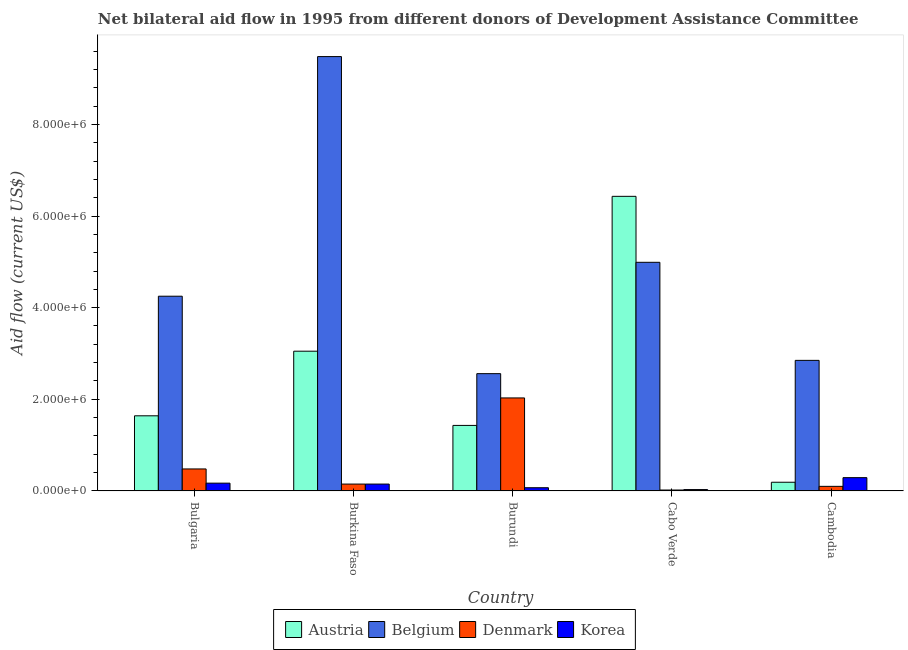How many groups of bars are there?
Your answer should be compact. 5. Are the number of bars on each tick of the X-axis equal?
Ensure brevity in your answer.  Yes. How many bars are there on the 3rd tick from the left?
Your answer should be very brief. 4. How many bars are there on the 3rd tick from the right?
Ensure brevity in your answer.  4. What is the label of the 1st group of bars from the left?
Give a very brief answer. Bulgaria. In how many cases, is the number of bars for a given country not equal to the number of legend labels?
Your response must be concise. 0. What is the amount of aid given by belgium in Cabo Verde?
Provide a short and direct response. 4.99e+06. Across all countries, what is the maximum amount of aid given by belgium?
Keep it short and to the point. 9.48e+06. Across all countries, what is the minimum amount of aid given by belgium?
Ensure brevity in your answer.  2.56e+06. In which country was the amount of aid given by austria maximum?
Provide a short and direct response. Cabo Verde. In which country was the amount of aid given by belgium minimum?
Offer a terse response. Burundi. What is the total amount of aid given by belgium in the graph?
Make the answer very short. 2.41e+07. What is the difference between the amount of aid given by korea in Burundi and that in Cambodia?
Your answer should be compact. -2.20e+05. What is the difference between the amount of aid given by austria in Bulgaria and the amount of aid given by denmark in Burkina Faso?
Make the answer very short. 1.49e+06. What is the average amount of aid given by belgium per country?
Make the answer very short. 4.83e+06. What is the difference between the amount of aid given by denmark and amount of aid given by korea in Cambodia?
Provide a succinct answer. -1.90e+05. In how many countries, is the amount of aid given by belgium greater than 5600000 US$?
Your response must be concise. 1. What is the ratio of the amount of aid given by austria in Bulgaria to that in Burundi?
Give a very brief answer. 1.15. Is the amount of aid given by austria in Bulgaria less than that in Cabo Verde?
Your response must be concise. Yes. Is the difference between the amount of aid given by belgium in Bulgaria and Cabo Verde greater than the difference between the amount of aid given by denmark in Bulgaria and Cabo Verde?
Ensure brevity in your answer.  No. What is the difference between the highest and the second highest amount of aid given by korea?
Give a very brief answer. 1.20e+05. What is the difference between the highest and the lowest amount of aid given by korea?
Provide a succinct answer. 2.60e+05. Is the sum of the amount of aid given by korea in Burundi and Cabo Verde greater than the maximum amount of aid given by belgium across all countries?
Make the answer very short. No. What does the 2nd bar from the left in Bulgaria represents?
Your answer should be very brief. Belgium. What does the 2nd bar from the right in Bulgaria represents?
Keep it short and to the point. Denmark. Is it the case that in every country, the sum of the amount of aid given by austria and amount of aid given by belgium is greater than the amount of aid given by denmark?
Give a very brief answer. Yes. How many bars are there?
Make the answer very short. 20. How are the legend labels stacked?
Keep it short and to the point. Horizontal. What is the title of the graph?
Make the answer very short. Net bilateral aid flow in 1995 from different donors of Development Assistance Committee. What is the Aid flow (current US$) in Austria in Bulgaria?
Make the answer very short. 1.64e+06. What is the Aid flow (current US$) in Belgium in Bulgaria?
Make the answer very short. 4.25e+06. What is the Aid flow (current US$) of Denmark in Bulgaria?
Offer a terse response. 4.80e+05. What is the Aid flow (current US$) in Austria in Burkina Faso?
Provide a short and direct response. 3.05e+06. What is the Aid flow (current US$) in Belgium in Burkina Faso?
Give a very brief answer. 9.48e+06. What is the Aid flow (current US$) in Korea in Burkina Faso?
Your answer should be very brief. 1.50e+05. What is the Aid flow (current US$) of Austria in Burundi?
Your answer should be compact. 1.43e+06. What is the Aid flow (current US$) of Belgium in Burundi?
Keep it short and to the point. 2.56e+06. What is the Aid flow (current US$) in Denmark in Burundi?
Make the answer very short. 2.03e+06. What is the Aid flow (current US$) of Austria in Cabo Verde?
Your answer should be compact. 6.43e+06. What is the Aid flow (current US$) in Belgium in Cabo Verde?
Keep it short and to the point. 4.99e+06. What is the Aid flow (current US$) of Denmark in Cabo Verde?
Your response must be concise. 2.00e+04. What is the Aid flow (current US$) of Belgium in Cambodia?
Your answer should be very brief. 2.85e+06. What is the Aid flow (current US$) in Denmark in Cambodia?
Your answer should be very brief. 1.00e+05. Across all countries, what is the maximum Aid flow (current US$) in Austria?
Your answer should be very brief. 6.43e+06. Across all countries, what is the maximum Aid flow (current US$) in Belgium?
Keep it short and to the point. 9.48e+06. Across all countries, what is the maximum Aid flow (current US$) of Denmark?
Give a very brief answer. 2.03e+06. Across all countries, what is the maximum Aid flow (current US$) in Korea?
Offer a very short reply. 2.90e+05. Across all countries, what is the minimum Aid flow (current US$) of Belgium?
Give a very brief answer. 2.56e+06. Across all countries, what is the minimum Aid flow (current US$) of Denmark?
Your response must be concise. 2.00e+04. Across all countries, what is the minimum Aid flow (current US$) in Korea?
Provide a succinct answer. 3.00e+04. What is the total Aid flow (current US$) of Austria in the graph?
Your answer should be compact. 1.27e+07. What is the total Aid flow (current US$) of Belgium in the graph?
Ensure brevity in your answer.  2.41e+07. What is the total Aid flow (current US$) in Denmark in the graph?
Provide a short and direct response. 2.78e+06. What is the total Aid flow (current US$) in Korea in the graph?
Make the answer very short. 7.10e+05. What is the difference between the Aid flow (current US$) in Austria in Bulgaria and that in Burkina Faso?
Provide a succinct answer. -1.41e+06. What is the difference between the Aid flow (current US$) in Belgium in Bulgaria and that in Burkina Faso?
Keep it short and to the point. -5.23e+06. What is the difference between the Aid flow (current US$) in Denmark in Bulgaria and that in Burkina Faso?
Ensure brevity in your answer.  3.30e+05. What is the difference between the Aid flow (current US$) in Austria in Bulgaria and that in Burundi?
Offer a terse response. 2.10e+05. What is the difference between the Aid flow (current US$) of Belgium in Bulgaria and that in Burundi?
Your response must be concise. 1.69e+06. What is the difference between the Aid flow (current US$) in Denmark in Bulgaria and that in Burundi?
Make the answer very short. -1.55e+06. What is the difference between the Aid flow (current US$) of Korea in Bulgaria and that in Burundi?
Your answer should be compact. 1.00e+05. What is the difference between the Aid flow (current US$) of Austria in Bulgaria and that in Cabo Verde?
Ensure brevity in your answer.  -4.79e+06. What is the difference between the Aid flow (current US$) in Belgium in Bulgaria and that in Cabo Verde?
Offer a terse response. -7.40e+05. What is the difference between the Aid flow (current US$) in Austria in Bulgaria and that in Cambodia?
Your response must be concise. 1.45e+06. What is the difference between the Aid flow (current US$) of Belgium in Bulgaria and that in Cambodia?
Your answer should be compact. 1.40e+06. What is the difference between the Aid flow (current US$) in Austria in Burkina Faso and that in Burundi?
Give a very brief answer. 1.62e+06. What is the difference between the Aid flow (current US$) in Belgium in Burkina Faso and that in Burundi?
Make the answer very short. 6.92e+06. What is the difference between the Aid flow (current US$) in Denmark in Burkina Faso and that in Burundi?
Keep it short and to the point. -1.88e+06. What is the difference between the Aid flow (current US$) in Korea in Burkina Faso and that in Burundi?
Your answer should be compact. 8.00e+04. What is the difference between the Aid flow (current US$) in Austria in Burkina Faso and that in Cabo Verde?
Your response must be concise. -3.38e+06. What is the difference between the Aid flow (current US$) in Belgium in Burkina Faso and that in Cabo Verde?
Make the answer very short. 4.49e+06. What is the difference between the Aid flow (current US$) in Austria in Burkina Faso and that in Cambodia?
Ensure brevity in your answer.  2.86e+06. What is the difference between the Aid flow (current US$) of Belgium in Burkina Faso and that in Cambodia?
Provide a succinct answer. 6.63e+06. What is the difference between the Aid flow (current US$) in Austria in Burundi and that in Cabo Verde?
Your response must be concise. -5.00e+06. What is the difference between the Aid flow (current US$) of Belgium in Burundi and that in Cabo Verde?
Make the answer very short. -2.43e+06. What is the difference between the Aid flow (current US$) of Denmark in Burundi and that in Cabo Verde?
Give a very brief answer. 2.01e+06. What is the difference between the Aid flow (current US$) of Korea in Burundi and that in Cabo Verde?
Your response must be concise. 4.00e+04. What is the difference between the Aid flow (current US$) in Austria in Burundi and that in Cambodia?
Your answer should be very brief. 1.24e+06. What is the difference between the Aid flow (current US$) in Denmark in Burundi and that in Cambodia?
Offer a very short reply. 1.93e+06. What is the difference between the Aid flow (current US$) of Korea in Burundi and that in Cambodia?
Give a very brief answer. -2.20e+05. What is the difference between the Aid flow (current US$) of Austria in Cabo Verde and that in Cambodia?
Ensure brevity in your answer.  6.24e+06. What is the difference between the Aid flow (current US$) in Belgium in Cabo Verde and that in Cambodia?
Your response must be concise. 2.14e+06. What is the difference between the Aid flow (current US$) of Denmark in Cabo Verde and that in Cambodia?
Ensure brevity in your answer.  -8.00e+04. What is the difference between the Aid flow (current US$) of Korea in Cabo Verde and that in Cambodia?
Your response must be concise. -2.60e+05. What is the difference between the Aid flow (current US$) in Austria in Bulgaria and the Aid flow (current US$) in Belgium in Burkina Faso?
Provide a short and direct response. -7.84e+06. What is the difference between the Aid flow (current US$) in Austria in Bulgaria and the Aid flow (current US$) in Denmark in Burkina Faso?
Offer a terse response. 1.49e+06. What is the difference between the Aid flow (current US$) of Austria in Bulgaria and the Aid flow (current US$) of Korea in Burkina Faso?
Give a very brief answer. 1.49e+06. What is the difference between the Aid flow (current US$) in Belgium in Bulgaria and the Aid flow (current US$) in Denmark in Burkina Faso?
Offer a terse response. 4.10e+06. What is the difference between the Aid flow (current US$) in Belgium in Bulgaria and the Aid flow (current US$) in Korea in Burkina Faso?
Offer a terse response. 4.10e+06. What is the difference between the Aid flow (current US$) in Denmark in Bulgaria and the Aid flow (current US$) in Korea in Burkina Faso?
Give a very brief answer. 3.30e+05. What is the difference between the Aid flow (current US$) in Austria in Bulgaria and the Aid flow (current US$) in Belgium in Burundi?
Your response must be concise. -9.20e+05. What is the difference between the Aid flow (current US$) of Austria in Bulgaria and the Aid flow (current US$) of Denmark in Burundi?
Keep it short and to the point. -3.90e+05. What is the difference between the Aid flow (current US$) in Austria in Bulgaria and the Aid flow (current US$) in Korea in Burundi?
Ensure brevity in your answer.  1.57e+06. What is the difference between the Aid flow (current US$) of Belgium in Bulgaria and the Aid flow (current US$) of Denmark in Burundi?
Make the answer very short. 2.22e+06. What is the difference between the Aid flow (current US$) in Belgium in Bulgaria and the Aid flow (current US$) in Korea in Burundi?
Offer a very short reply. 4.18e+06. What is the difference between the Aid flow (current US$) of Denmark in Bulgaria and the Aid flow (current US$) of Korea in Burundi?
Offer a very short reply. 4.10e+05. What is the difference between the Aid flow (current US$) of Austria in Bulgaria and the Aid flow (current US$) of Belgium in Cabo Verde?
Offer a terse response. -3.35e+06. What is the difference between the Aid flow (current US$) of Austria in Bulgaria and the Aid flow (current US$) of Denmark in Cabo Verde?
Offer a very short reply. 1.62e+06. What is the difference between the Aid flow (current US$) in Austria in Bulgaria and the Aid flow (current US$) in Korea in Cabo Verde?
Make the answer very short. 1.61e+06. What is the difference between the Aid flow (current US$) in Belgium in Bulgaria and the Aid flow (current US$) in Denmark in Cabo Verde?
Your answer should be compact. 4.23e+06. What is the difference between the Aid flow (current US$) of Belgium in Bulgaria and the Aid flow (current US$) of Korea in Cabo Verde?
Provide a succinct answer. 4.22e+06. What is the difference between the Aid flow (current US$) of Denmark in Bulgaria and the Aid flow (current US$) of Korea in Cabo Verde?
Your answer should be compact. 4.50e+05. What is the difference between the Aid flow (current US$) of Austria in Bulgaria and the Aid flow (current US$) of Belgium in Cambodia?
Your answer should be very brief. -1.21e+06. What is the difference between the Aid flow (current US$) of Austria in Bulgaria and the Aid flow (current US$) of Denmark in Cambodia?
Give a very brief answer. 1.54e+06. What is the difference between the Aid flow (current US$) of Austria in Bulgaria and the Aid flow (current US$) of Korea in Cambodia?
Offer a very short reply. 1.35e+06. What is the difference between the Aid flow (current US$) in Belgium in Bulgaria and the Aid flow (current US$) in Denmark in Cambodia?
Give a very brief answer. 4.15e+06. What is the difference between the Aid flow (current US$) of Belgium in Bulgaria and the Aid flow (current US$) of Korea in Cambodia?
Your answer should be very brief. 3.96e+06. What is the difference between the Aid flow (current US$) of Denmark in Bulgaria and the Aid flow (current US$) of Korea in Cambodia?
Your answer should be compact. 1.90e+05. What is the difference between the Aid flow (current US$) of Austria in Burkina Faso and the Aid flow (current US$) of Denmark in Burundi?
Give a very brief answer. 1.02e+06. What is the difference between the Aid flow (current US$) in Austria in Burkina Faso and the Aid flow (current US$) in Korea in Burundi?
Keep it short and to the point. 2.98e+06. What is the difference between the Aid flow (current US$) of Belgium in Burkina Faso and the Aid flow (current US$) of Denmark in Burundi?
Provide a succinct answer. 7.45e+06. What is the difference between the Aid flow (current US$) in Belgium in Burkina Faso and the Aid flow (current US$) in Korea in Burundi?
Ensure brevity in your answer.  9.41e+06. What is the difference between the Aid flow (current US$) in Denmark in Burkina Faso and the Aid flow (current US$) in Korea in Burundi?
Provide a short and direct response. 8.00e+04. What is the difference between the Aid flow (current US$) in Austria in Burkina Faso and the Aid flow (current US$) in Belgium in Cabo Verde?
Provide a short and direct response. -1.94e+06. What is the difference between the Aid flow (current US$) of Austria in Burkina Faso and the Aid flow (current US$) of Denmark in Cabo Verde?
Make the answer very short. 3.03e+06. What is the difference between the Aid flow (current US$) in Austria in Burkina Faso and the Aid flow (current US$) in Korea in Cabo Verde?
Provide a short and direct response. 3.02e+06. What is the difference between the Aid flow (current US$) of Belgium in Burkina Faso and the Aid flow (current US$) of Denmark in Cabo Verde?
Provide a short and direct response. 9.46e+06. What is the difference between the Aid flow (current US$) in Belgium in Burkina Faso and the Aid flow (current US$) in Korea in Cabo Verde?
Offer a very short reply. 9.45e+06. What is the difference between the Aid flow (current US$) of Austria in Burkina Faso and the Aid flow (current US$) of Denmark in Cambodia?
Keep it short and to the point. 2.95e+06. What is the difference between the Aid flow (current US$) of Austria in Burkina Faso and the Aid flow (current US$) of Korea in Cambodia?
Offer a very short reply. 2.76e+06. What is the difference between the Aid flow (current US$) in Belgium in Burkina Faso and the Aid flow (current US$) in Denmark in Cambodia?
Your answer should be very brief. 9.38e+06. What is the difference between the Aid flow (current US$) of Belgium in Burkina Faso and the Aid flow (current US$) of Korea in Cambodia?
Provide a succinct answer. 9.19e+06. What is the difference between the Aid flow (current US$) in Austria in Burundi and the Aid flow (current US$) in Belgium in Cabo Verde?
Make the answer very short. -3.56e+06. What is the difference between the Aid flow (current US$) of Austria in Burundi and the Aid flow (current US$) of Denmark in Cabo Verde?
Your response must be concise. 1.41e+06. What is the difference between the Aid flow (current US$) in Austria in Burundi and the Aid flow (current US$) in Korea in Cabo Verde?
Ensure brevity in your answer.  1.40e+06. What is the difference between the Aid flow (current US$) in Belgium in Burundi and the Aid flow (current US$) in Denmark in Cabo Verde?
Your answer should be very brief. 2.54e+06. What is the difference between the Aid flow (current US$) in Belgium in Burundi and the Aid flow (current US$) in Korea in Cabo Verde?
Ensure brevity in your answer.  2.53e+06. What is the difference between the Aid flow (current US$) in Denmark in Burundi and the Aid flow (current US$) in Korea in Cabo Verde?
Provide a short and direct response. 2.00e+06. What is the difference between the Aid flow (current US$) of Austria in Burundi and the Aid flow (current US$) of Belgium in Cambodia?
Your answer should be very brief. -1.42e+06. What is the difference between the Aid flow (current US$) of Austria in Burundi and the Aid flow (current US$) of Denmark in Cambodia?
Your answer should be very brief. 1.33e+06. What is the difference between the Aid flow (current US$) in Austria in Burundi and the Aid flow (current US$) in Korea in Cambodia?
Give a very brief answer. 1.14e+06. What is the difference between the Aid flow (current US$) in Belgium in Burundi and the Aid flow (current US$) in Denmark in Cambodia?
Your response must be concise. 2.46e+06. What is the difference between the Aid flow (current US$) of Belgium in Burundi and the Aid flow (current US$) of Korea in Cambodia?
Your answer should be very brief. 2.27e+06. What is the difference between the Aid flow (current US$) of Denmark in Burundi and the Aid flow (current US$) of Korea in Cambodia?
Your answer should be very brief. 1.74e+06. What is the difference between the Aid flow (current US$) of Austria in Cabo Verde and the Aid flow (current US$) of Belgium in Cambodia?
Offer a terse response. 3.58e+06. What is the difference between the Aid flow (current US$) of Austria in Cabo Verde and the Aid flow (current US$) of Denmark in Cambodia?
Offer a very short reply. 6.33e+06. What is the difference between the Aid flow (current US$) of Austria in Cabo Verde and the Aid flow (current US$) of Korea in Cambodia?
Give a very brief answer. 6.14e+06. What is the difference between the Aid flow (current US$) of Belgium in Cabo Verde and the Aid flow (current US$) of Denmark in Cambodia?
Offer a terse response. 4.89e+06. What is the difference between the Aid flow (current US$) of Belgium in Cabo Verde and the Aid flow (current US$) of Korea in Cambodia?
Provide a short and direct response. 4.70e+06. What is the difference between the Aid flow (current US$) in Denmark in Cabo Verde and the Aid flow (current US$) in Korea in Cambodia?
Offer a very short reply. -2.70e+05. What is the average Aid flow (current US$) of Austria per country?
Offer a terse response. 2.55e+06. What is the average Aid flow (current US$) of Belgium per country?
Provide a short and direct response. 4.83e+06. What is the average Aid flow (current US$) of Denmark per country?
Offer a terse response. 5.56e+05. What is the average Aid flow (current US$) of Korea per country?
Offer a terse response. 1.42e+05. What is the difference between the Aid flow (current US$) in Austria and Aid flow (current US$) in Belgium in Bulgaria?
Give a very brief answer. -2.61e+06. What is the difference between the Aid flow (current US$) in Austria and Aid flow (current US$) in Denmark in Bulgaria?
Your answer should be compact. 1.16e+06. What is the difference between the Aid flow (current US$) of Austria and Aid flow (current US$) of Korea in Bulgaria?
Provide a short and direct response. 1.47e+06. What is the difference between the Aid flow (current US$) in Belgium and Aid flow (current US$) in Denmark in Bulgaria?
Keep it short and to the point. 3.77e+06. What is the difference between the Aid flow (current US$) of Belgium and Aid flow (current US$) of Korea in Bulgaria?
Offer a terse response. 4.08e+06. What is the difference between the Aid flow (current US$) in Austria and Aid flow (current US$) in Belgium in Burkina Faso?
Your answer should be compact. -6.43e+06. What is the difference between the Aid flow (current US$) in Austria and Aid flow (current US$) in Denmark in Burkina Faso?
Keep it short and to the point. 2.90e+06. What is the difference between the Aid flow (current US$) of Austria and Aid flow (current US$) of Korea in Burkina Faso?
Provide a short and direct response. 2.90e+06. What is the difference between the Aid flow (current US$) of Belgium and Aid flow (current US$) of Denmark in Burkina Faso?
Make the answer very short. 9.33e+06. What is the difference between the Aid flow (current US$) of Belgium and Aid flow (current US$) of Korea in Burkina Faso?
Give a very brief answer. 9.33e+06. What is the difference between the Aid flow (current US$) of Denmark and Aid flow (current US$) of Korea in Burkina Faso?
Offer a terse response. 0. What is the difference between the Aid flow (current US$) in Austria and Aid flow (current US$) in Belgium in Burundi?
Make the answer very short. -1.13e+06. What is the difference between the Aid flow (current US$) in Austria and Aid flow (current US$) in Denmark in Burundi?
Keep it short and to the point. -6.00e+05. What is the difference between the Aid flow (current US$) of Austria and Aid flow (current US$) of Korea in Burundi?
Keep it short and to the point. 1.36e+06. What is the difference between the Aid flow (current US$) in Belgium and Aid flow (current US$) in Denmark in Burundi?
Your answer should be compact. 5.30e+05. What is the difference between the Aid flow (current US$) of Belgium and Aid flow (current US$) of Korea in Burundi?
Give a very brief answer. 2.49e+06. What is the difference between the Aid flow (current US$) of Denmark and Aid flow (current US$) of Korea in Burundi?
Provide a succinct answer. 1.96e+06. What is the difference between the Aid flow (current US$) in Austria and Aid flow (current US$) in Belgium in Cabo Verde?
Your answer should be compact. 1.44e+06. What is the difference between the Aid flow (current US$) in Austria and Aid flow (current US$) in Denmark in Cabo Verde?
Offer a terse response. 6.41e+06. What is the difference between the Aid flow (current US$) of Austria and Aid flow (current US$) of Korea in Cabo Verde?
Provide a succinct answer. 6.40e+06. What is the difference between the Aid flow (current US$) in Belgium and Aid flow (current US$) in Denmark in Cabo Verde?
Keep it short and to the point. 4.97e+06. What is the difference between the Aid flow (current US$) in Belgium and Aid flow (current US$) in Korea in Cabo Verde?
Provide a short and direct response. 4.96e+06. What is the difference between the Aid flow (current US$) in Austria and Aid flow (current US$) in Belgium in Cambodia?
Provide a succinct answer. -2.66e+06. What is the difference between the Aid flow (current US$) in Austria and Aid flow (current US$) in Denmark in Cambodia?
Provide a short and direct response. 9.00e+04. What is the difference between the Aid flow (current US$) in Austria and Aid flow (current US$) in Korea in Cambodia?
Ensure brevity in your answer.  -1.00e+05. What is the difference between the Aid flow (current US$) of Belgium and Aid flow (current US$) of Denmark in Cambodia?
Keep it short and to the point. 2.75e+06. What is the difference between the Aid flow (current US$) in Belgium and Aid flow (current US$) in Korea in Cambodia?
Provide a succinct answer. 2.56e+06. What is the ratio of the Aid flow (current US$) of Austria in Bulgaria to that in Burkina Faso?
Your answer should be compact. 0.54. What is the ratio of the Aid flow (current US$) in Belgium in Bulgaria to that in Burkina Faso?
Keep it short and to the point. 0.45. What is the ratio of the Aid flow (current US$) in Denmark in Bulgaria to that in Burkina Faso?
Your answer should be very brief. 3.2. What is the ratio of the Aid flow (current US$) of Korea in Bulgaria to that in Burkina Faso?
Provide a succinct answer. 1.13. What is the ratio of the Aid flow (current US$) in Austria in Bulgaria to that in Burundi?
Make the answer very short. 1.15. What is the ratio of the Aid flow (current US$) of Belgium in Bulgaria to that in Burundi?
Keep it short and to the point. 1.66. What is the ratio of the Aid flow (current US$) in Denmark in Bulgaria to that in Burundi?
Your response must be concise. 0.24. What is the ratio of the Aid flow (current US$) in Korea in Bulgaria to that in Burundi?
Your answer should be very brief. 2.43. What is the ratio of the Aid flow (current US$) in Austria in Bulgaria to that in Cabo Verde?
Provide a succinct answer. 0.26. What is the ratio of the Aid flow (current US$) in Belgium in Bulgaria to that in Cabo Verde?
Offer a terse response. 0.85. What is the ratio of the Aid flow (current US$) of Denmark in Bulgaria to that in Cabo Verde?
Keep it short and to the point. 24. What is the ratio of the Aid flow (current US$) of Korea in Bulgaria to that in Cabo Verde?
Provide a succinct answer. 5.67. What is the ratio of the Aid flow (current US$) in Austria in Bulgaria to that in Cambodia?
Provide a short and direct response. 8.63. What is the ratio of the Aid flow (current US$) of Belgium in Bulgaria to that in Cambodia?
Ensure brevity in your answer.  1.49. What is the ratio of the Aid flow (current US$) in Denmark in Bulgaria to that in Cambodia?
Offer a very short reply. 4.8. What is the ratio of the Aid flow (current US$) of Korea in Bulgaria to that in Cambodia?
Keep it short and to the point. 0.59. What is the ratio of the Aid flow (current US$) of Austria in Burkina Faso to that in Burundi?
Keep it short and to the point. 2.13. What is the ratio of the Aid flow (current US$) of Belgium in Burkina Faso to that in Burundi?
Your response must be concise. 3.7. What is the ratio of the Aid flow (current US$) of Denmark in Burkina Faso to that in Burundi?
Make the answer very short. 0.07. What is the ratio of the Aid flow (current US$) of Korea in Burkina Faso to that in Burundi?
Your answer should be compact. 2.14. What is the ratio of the Aid flow (current US$) in Austria in Burkina Faso to that in Cabo Verde?
Your response must be concise. 0.47. What is the ratio of the Aid flow (current US$) in Belgium in Burkina Faso to that in Cabo Verde?
Provide a succinct answer. 1.9. What is the ratio of the Aid flow (current US$) in Austria in Burkina Faso to that in Cambodia?
Your response must be concise. 16.05. What is the ratio of the Aid flow (current US$) of Belgium in Burkina Faso to that in Cambodia?
Offer a terse response. 3.33. What is the ratio of the Aid flow (current US$) in Korea in Burkina Faso to that in Cambodia?
Provide a short and direct response. 0.52. What is the ratio of the Aid flow (current US$) in Austria in Burundi to that in Cabo Verde?
Ensure brevity in your answer.  0.22. What is the ratio of the Aid flow (current US$) in Belgium in Burundi to that in Cabo Verde?
Offer a terse response. 0.51. What is the ratio of the Aid flow (current US$) of Denmark in Burundi to that in Cabo Verde?
Your answer should be compact. 101.5. What is the ratio of the Aid flow (current US$) of Korea in Burundi to that in Cabo Verde?
Offer a very short reply. 2.33. What is the ratio of the Aid flow (current US$) of Austria in Burundi to that in Cambodia?
Offer a very short reply. 7.53. What is the ratio of the Aid flow (current US$) in Belgium in Burundi to that in Cambodia?
Make the answer very short. 0.9. What is the ratio of the Aid flow (current US$) in Denmark in Burundi to that in Cambodia?
Make the answer very short. 20.3. What is the ratio of the Aid flow (current US$) of Korea in Burundi to that in Cambodia?
Keep it short and to the point. 0.24. What is the ratio of the Aid flow (current US$) of Austria in Cabo Verde to that in Cambodia?
Your answer should be very brief. 33.84. What is the ratio of the Aid flow (current US$) of Belgium in Cabo Verde to that in Cambodia?
Your answer should be very brief. 1.75. What is the ratio of the Aid flow (current US$) of Korea in Cabo Verde to that in Cambodia?
Provide a short and direct response. 0.1. What is the difference between the highest and the second highest Aid flow (current US$) in Austria?
Offer a terse response. 3.38e+06. What is the difference between the highest and the second highest Aid flow (current US$) in Belgium?
Keep it short and to the point. 4.49e+06. What is the difference between the highest and the second highest Aid flow (current US$) of Denmark?
Offer a very short reply. 1.55e+06. What is the difference between the highest and the lowest Aid flow (current US$) of Austria?
Offer a very short reply. 6.24e+06. What is the difference between the highest and the lowest Aid flow (current US$) of Belgium?
Ensure brevity in your answer.  6.92e+06. What is the difference between the highest and the lowest Aid flow (current US$) of Denmark?
Your answer should be compact. 2.01e+06. 